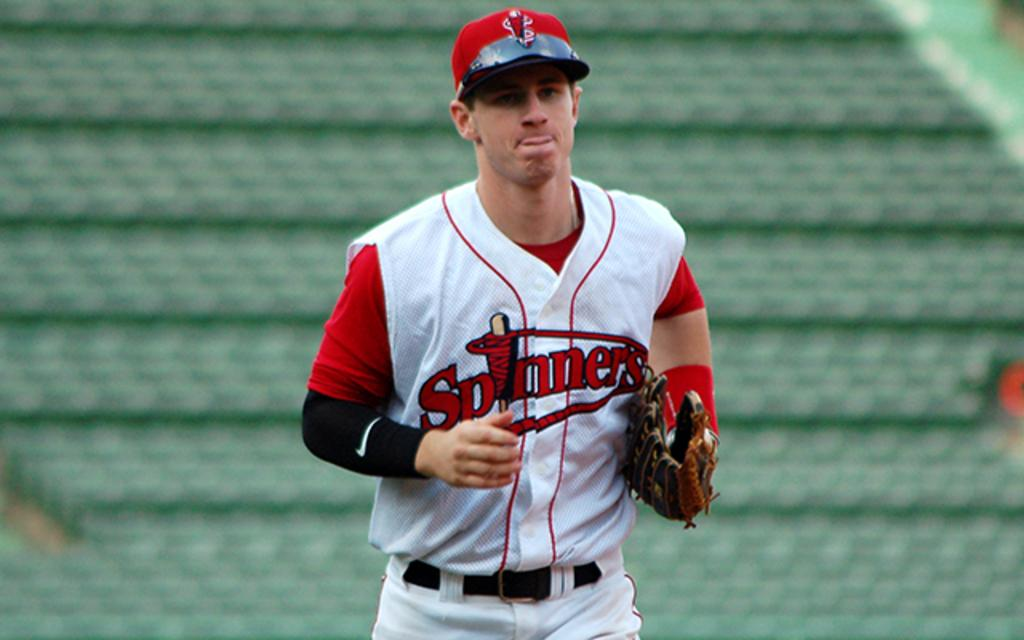What is the main subject of the image? There is a person in the image. What is the person wearing on their head? The person is wearing a cap. What type of clothing is the person wearing? The person is wearing clothes. What type of accessory is the person wearing on their hand? The person is wearing a glove. Can you describe the background of the image? The background of the image is blurred. How many toes can be seen in the image? There are no toes visible in the image, as the person is wearing a glove on their hand, not on their foot. 